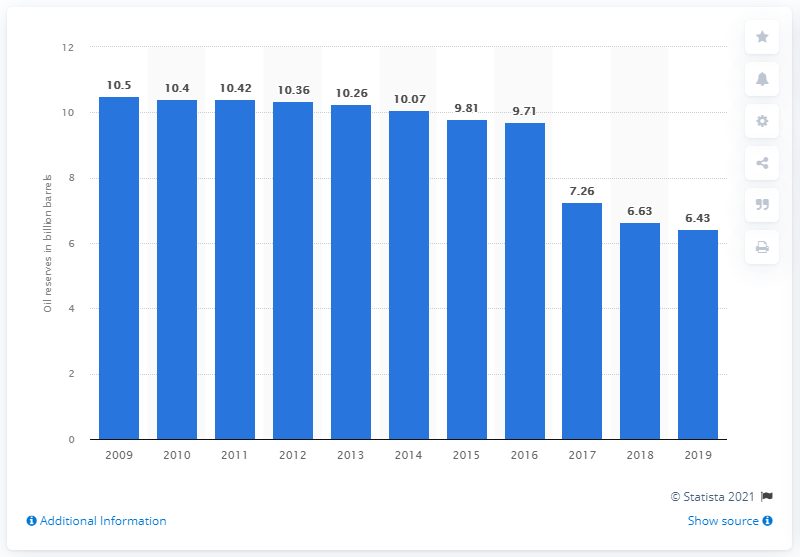List a handful of essential elements in this visual. In 2019, Mexico's crude oil reserves were 6.43 billion barrels. 